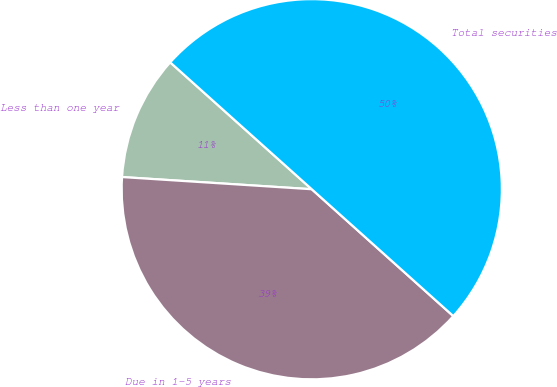Convert chart to OTSL. <chart><loc_0><loc_0><loc_500><loc_500><pie_chart><fcel>Less than one year<fcel>Due in 1-5 years<fcel>Total securities<nl><fcel>10.61%<fcel>39.39%<fcel>50.0%<nl></chart> 